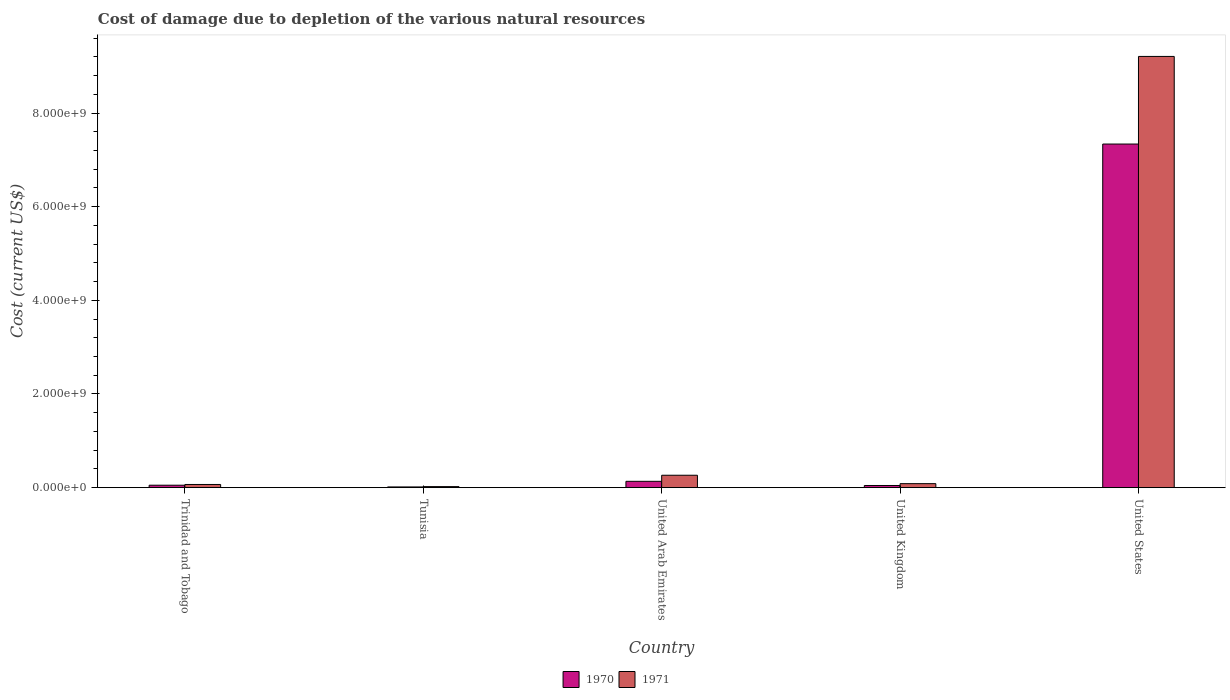How many different coloured bars are there?
Ensure brevity in your answer.  2. How many groups of bars are there?
Your answer should be compact. 5. Are the number of bars per tick equal to the number of legend labels?
Your answer should be compact. Yes. Are the number of bars on each tick of the X-axis equal?
Give a very brief answer. Yes. How many bars are there on the 3rd tick from the right?
Provide a succinct answer. 2. What is the label of the 3rd group of bars from the left?
Your answer should be compact. United Arab Emirates. In how many cases, is the number of bars for a given country not equal to the number of legend labels?
Give a very brief answer. 0. What is the cost of damage caused due to the depletion of various natural resources in 1971 in United Kingdom?
Offer a very short reply. 8.52e+07. Across all countries, what is the maximum cost of damage caused due to the depletion of various natural resources in 1970?
Make the answer very short. 7.34e+09. Across all countries, what is the minimum cost of damage caused due to the depletion of various natural resources in 1970?
Provide a short and direct response. 1.51e+07. In which country was the cost of damage caused due to the depletion of various natural resources in 1971 maximum?
Your response must be concise. United States. In which country was the cost of damage caused due to the depletion of various natural resources in 1970 minimum?
Offer a very short reply. Tunisia. What is the total cost of damage caused due to the depletion of various natural resources in 1971 in the graph?
Provide a succinct answer. 9.65e+09. What is the difference between the cost of damage caused due to the depletion of various natural resources in 1970 in Trinidad and Tobago and that in Tunisia?
Your answer should be compact. 3.68e+07. What is the difference between the cost of damage caused due to the depletion of various natural resources in 1971 in United States and the cost of damage caused due to the depletion of various natural resources in 1970 in Tunisia?
Your answer should be very brief. 9.19e+09. What is the average cost of damage caused due to the depletion of various natural resources in 1970 per country?
Offer a very short reply. 1.52e+09. What is the difference between the cost of damage caused due to the depletion of various natural resources of/in 1971 and cost of damage caused due to the depletion of various natural resources of/in 1970 in United Kingdom?
Offer a very short reply. 3.95e+07. In how many countries, is the cost of damage caused due to the depletion of various natural resources in 1971 greater than 800000000 US$?
Offer a very short reply. 1. What is the ratio of the cost of damage caused due to the depletion of various natural resources in 1970 in United Kingdom to that in United States?
Offer a terse response. 0.01. Is the cost of damage caused due to the depletion of various natural resources in 1970 in Trinidad and Tobago less than that in United States?
Make the answer very short. Yes. Is the difference between the cost of damage caused due to the depletion of various natural resources in 1971 in Tunisia and United Kingdom greater than the difference between the cost of damage caused due to the depletion of various natural resources in 1970 in Tunisia and United Kingdom?
Your answer should be very brief. No. What is the difference between the highest and the second highest cost of damage caused due to the depletion of various natural resources in 1970?
Offer a very short reply. -7.29e+09. What is the difference between the highest and the lowest cost of damage caused due to the depletion of various natural resources in 1971?
Give a very brief answer. 9.19e+09. In how many countries, is the cost of damage caused due to the depletion of various natural resources in 1971 greater than the average cost of damage caused due to the depletion of various natural resources in 1971 taken over all countries?
Ensure brevity in your answer.  1. What does the 2nd bar from the left in Tunisia represents?
Provide a succinct answer. 1971. Are all the bars in the graph horizontal?
Give a very brief answer. No. How many countries are there in the graph?
Give a very brief answer. 5. Are the values on the major ticks of Y-axis written in scientific E-notation?
Provide a short and direct response. Yes. Does the graph contain any zero values?
Provide a succinct answer. No. Where does the legend appear in the graph?
Provide a succinct answer. Bottom center. How are the legend labels stacked?
Ensure brevity in your answer.  Horizontal. What is the title of the graph?
Your answer should be compact. Cost of damage due to depletion of the various natural resources. Does "1972" appear as one of the legend labels in the graph?
Offer a terse response. No. What is the label or title of the Y-axis?
Your answer should be compact. Cost (current US$). What is the Cost (current US$) of 1970 in Trinidad and Tobago?
Make the answer very short. 5.19e+07. What is the Cost (current US$) of 1971 in Trinidad and Tobago?
Make the answer very short. 6.76e+07. What is the Cost (current US$) of 1970 in Tunisia?
Your answer should be compact. 1.51e+07. What is the Cost (current US$) in 1971 in Tunisia?
Provide a short and direct response. 2.18e+07. What is the Cost (current US$) of 1970 in United Arab Emirates?
Ensure brevity in your answer.  1.35e+08. What is the Cost (current US$) of 1971 in United Arab Emirates?
Offer a very short reply. 2.65e+08. What is the Cost (current US$) in 1970 in United Kingdom?
Give a very brief answer. 4.58e+07. What is the Cost (current US$) of 1971 in United Kingdom?
Offer a very short reply. 8.52e+07. What is the Cost (current US$) of 1970 in United States?
Give a very brief answer. 7.34e+09. What is the Cost (current US$) in 1971 in United States?
Offer a terse response. 9.21e+09. Across all countries, what is the maximum Cost (current US$) in 1970?
Your answer should be very brief. 7.34e+09. Across all countries, what is the maximum Cost (current US$) of 1971?
Ensure brevity in your answer.  9.21e+09. Across all countries, what is the minimum Cost (current US$) in 1970?
Provide a short and direct response. 1.51e+07. Across all countries, what is the minimum Cost (current US$) of 1971?
Your answer should be compact. 2.18e+07. What is the total Cost (current US$) in 1970 in the graph?
Offer a very short reply. 7.59e+09. What is the total Cost (current US$) of 1971 in the graph?
Provide a succinct answer. 9.65e+09. What is the difference between the Cost (current US$) in 1970 in Trinidad and Tobago and that in Tunisia?
Provide a short and direct response. 3.68e+07. What is the difference between the Cost (current US$) in 1971 in Trinidad and Tobago and that in Tunisia?
Your answer should be very brief. 4.58e+07. What is the difference between the Cost (current US$) in 1970 in Trinidad and Tobago and that in United Arab Emirates?
Make the answer very short. -8.33e+07. What is the difference between the Cost (current US$) in 1971 in Trinidad and Tobago and that in United Arab Emirates?
Your answer should be very brief. -1.97e+08. What is the difference between the Cost (current US$) of 1970 in Trinidad and Tobago and that in United Kingdom?
Keep it short and to the point. 6.11e+06. What is the difference between the Cost (current US$) of 1971 in Trinidad and Tobago and that in United Kingdom?
Make the answer very short. -1.76e+07. What is the difference between the Cost (current US$) of 1970 in Trinidad and Tobago and that in United States?
Give a very brief answer. -7.29e+09. What is the difference between the Cost (current US$) of 1971 in Trinidad and Tobago and that in United States?
Your answer should be compact. -9.14e+09. What is the difference between the Cost (current US$) of 1970 in Tunisia and that in United Arab Emirates?
Make the answer very short. -1.20e+08. What is the difference between the Cost (current US$) of 1971 in Tunisia and that in United Arab Emirates?
Provide a short and direct response. -2.43e+08. What is the difference between the Cost (current US$) in 1970 in Tunisia and that in United Kingdom?
Your response must be concise. -3.07e+07. What is the difference between the Cost (current US$) of 1971 in Tunisia and that in United Kingdom?
Ensure brevity in your answer.  -6.34e+07. What is the difference between the Cost (current US$) in 1970 in Tunisia and that in United States?
Offer a very short reply. -7.32e+09. What is the difference between the Cost (current US$) of 1971 in Tunisia and that in United States?
Provide a short and direct response. -9.19e+09. What is the difference between the Cost (current US$) in 1970 in United Arab Emirates and that in United Kingdom?
Provide a succinct answer. 8.94e+07. What is the difference between the Cost (current US$) in 1971 in United Arab Emirates and that in United Kingdom?
Offer a very short reply. 1.80e+08. What is the difference between the Cost (current US$) of 1970 in United Arab Emirates and that in United States?
Your response must be concise. -7.20e+09. What is the difference between the Cost (current US$) of 1971 in United Arab Emirates and that in United States?
Make the answer very short. -8.94e+09. What is the difference between the Cost (current US$) in 1970 in United Kingdom and that in United States?
Give a very brief answer. -7.29e+09. What is the difference between the Cost (current US$) in 1971 in United Kingdom and that in United States?
Give a very brief answer. -9.12e+09. What is the difference between the Cost (current US$) in 1970 in Trinidad and Tobago and the Cost (current US$) in 1971 in Tunisia?
Make the answer very short. 3.01e+07. What is the difference between the Cost (current US$) of 1970 in Trinidad and Tobago and the Cost (current US$) of 1971 in United Arab Emirates?
Your answer should be very brief. -2.13e+08. What is the difference between the Cost (current US$) of 1970 in Trinidad and Tobago and the Cost (current US$) of 1971 in United Kingdom?
Provide a succinct answer. -3.34e+07. What is the difference between the Cost (current US$) of 1970 in Trinidad and Tobago and the Cost (current US$) of 1971 in United States?
Give a very brief answer. -9.16e+09. What is the difference between the Cost (current US$) in 1970 in Tunisia and the Cost (current US$) in 1971 in United Arab Emirates?
Make the answer very short. -2.50e+08. What is the difference between the Cost (current US$) in 1970 in Tunisia and the Cost (current US$) in 1971 in United Kingdom?
Your answer should be very brief. -7.02e+07. What is the difference between the Cost (current US$) in 1970 in Tunisia and the Cost (current US$) in 1971 in United States?
Your answer should be compact. -9.19e+09. What is the difference between the Cost (current US$) of 1970 in United Arab Emirates and the Cost (current US$) of 1971 in United Kingdom?
Ensure brevity in your answer.  4.99e+07. What is the difference between the Cost (current US$) of 1970 in United Arab Emirates and the Cost (current US$) of 1971 in United States?
Offer a very short reply. -9.07e+09. What is the difference between the Cost (current US$) in 1970 in United Kingdom and the Cost (current US$) in 1971 in United States?
Provide a succinct answer. -9.16e+09. What is the average Cost (current US$) of 1970 per country?
Your response must be concise. 1.52e+09. What is the average Cost (current US$) in 1971 per country?
Ensure brevity in your answer.  1.93e+09. What is the difference between the Cost (current US$) in 1970 and Cost (current US$) in 1971 in Trinidad and Tobago?
Provide a succinct answer. -1.57e+07. What is the difference between the Cost (current US$) in 1970 and Cost (current US$) in 1971 in Tunisia?
Give a very brief answer. -6.72e+06. What is the difference between the Cost (current US$) of 1970 and Cost (current US$) of 1971 in United Arab Emirates?
Your response must be concise. -1.30e+08. What is the difference between the Cost (current US$) of 1970 and Cost (current US$) of 1971 in United Kingdom?
Give a very brief answer. -3.95e+07. What is the difference between the Cost (current US$) of 1970 and Cost (current US$) of 1971 in United States?
Make the answer very short. -1.87e+09. What is the ratio of the Cost (current US$) of 1970 in Trinidad and Tobago to that in Tunisia?
Ensure brevity in your answer.  3.44. What is the ratio of the Cost (current US$) of 1971 in Trinidad and Tobago to that in Tunisia?
Provide a short and direct response. 3.1. What is the ratio of the Cost (current US$) of 1970 in Trinidad and Tobago to that in United Arab Emirates?
Offer a terse response. 0.38. What is the ratio of the Cost (current US$) of 1971 in Trinidad and Tobago to that in United Arab Emirates?
Your response must be concise. 0.26. What is the ratio of the Cost (current US$) in 1970 in Trinidad and Tobago to that in United Kingdom?
Provide a short and direct response. 1.13. What is the ratio of the Cost (current US$) in 1971 in Trinidad and Tobago to that in United Kingdom?
Your answer should be very brief. 0.79. What is the ratio of the Cost (current US$) of 1970 in Trinidad and Tobago to that in United States?
Your answer should be compact. 0.01. What is the ratio of the Cost (current US$) in 1971 in Trinidad and Tobago to that in United States?
Ensure brevity in your answer.  0.01. What is the ratio of the Cost (current US$) of 1970 in Tunisia to that in United Arab Emirates?
Offer a terse response. 0.11. What is the ratio of the Cost (current US$) of 1971 in Tunisia to that in United Arab Emirates?
Offer a very short reply. 0.08. What is the ratio of the Cost (current US$) in 1970 in Tunisia to that in United Kingdom?
Make the answer very short. 0.33. What is the ratio of the Cost (current US$) in 1971 in Tunisia to that in United Kingdom?
Provide a succinct answer. 0.26. What is the ratio of the Cost (current US$) in 1970 in Tunisia to that in United States?
Your answer should be compact. 0. What is the ratio of the Cost (current US$) of 1971 in Tunisia to that in United States?
Ensure brevity in your answer.  0. What is the ratio of the Cost (current US$) in 1970 in United Arab Emirates to that in United Kingdom?
Offer a terse response. 2.95. What is the ratio of the Cost (current US$) of 1971 in United Arab Emirates to that in United Kingdom?
Give a very brief answer. 3.11. What is the ratio of the Cost (current US$) of 1970 in United Arab Emirates to that in United States?
Offer a very short reply. 0.02. What is the ratio of the Cost (current US$) in 1971 in United Arab Emirates to that in United States?
Make the answer very short. 0.03. What is the ratio of the Cost (current US$) of 1970 in United Kingdom to that in United States?
Offer a very short reply. 0.01. What is the ratio of the Cost (current US$) of 1971 in United Kingdom to that in United States?
Your response must be concise. 0.01. What is the difference between the highest and the second highest Cost (current US$) of 1970?
Your answer should be compact. 7.20e+09. What is the difference between the highest and the second highest Cost (current US$) of 1971?
Provide a short and direct response. 8.94e+09. What is the difference between the highest and the lowest Cost (current US$) in 1970?
Provide a succinct answer. 7.32e+09. What is the difference between the highest and the lowest Cost (current US$) in 1971?
Ensure brevity in your answer.  9.19e+09. 